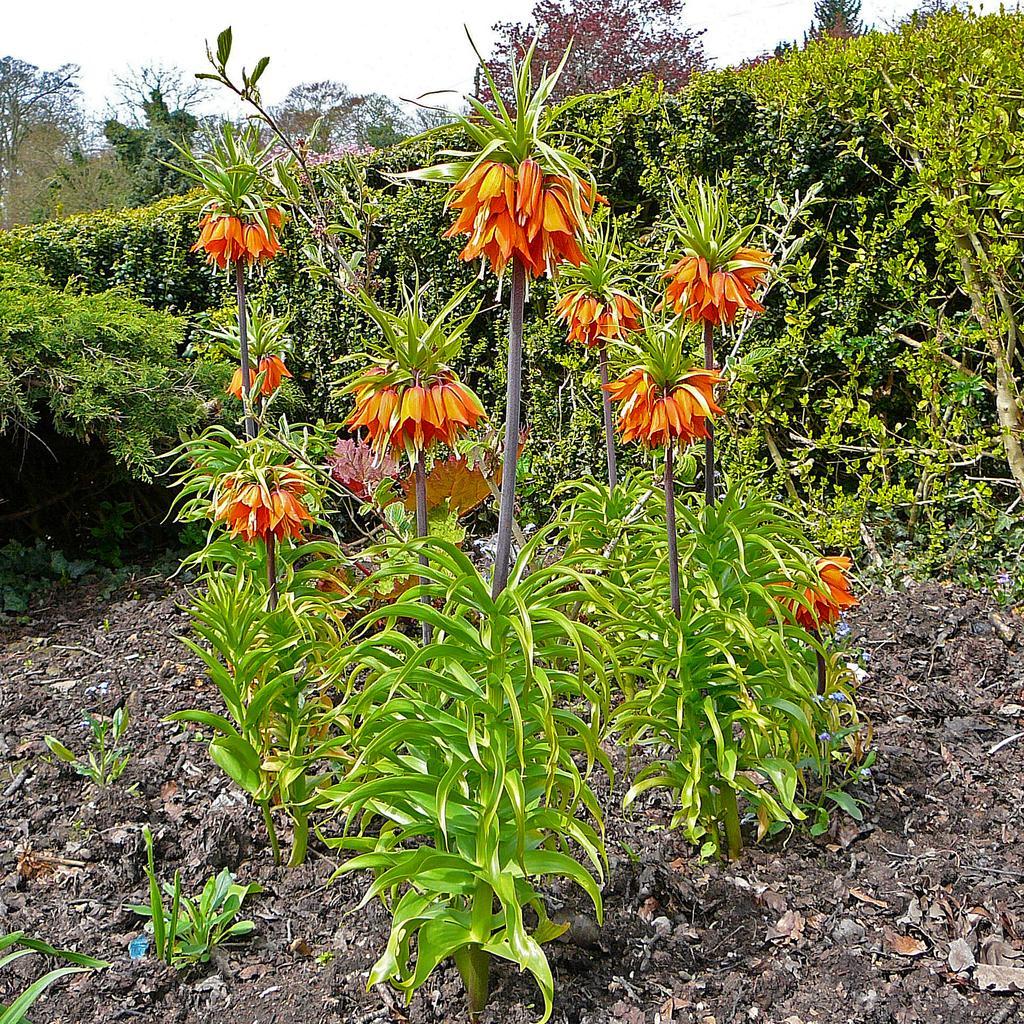In one or two sentences, can you explain what this image depicts? In the center of the image there are plants and we can see flowers. In the background there are trees, bushes and sky. 